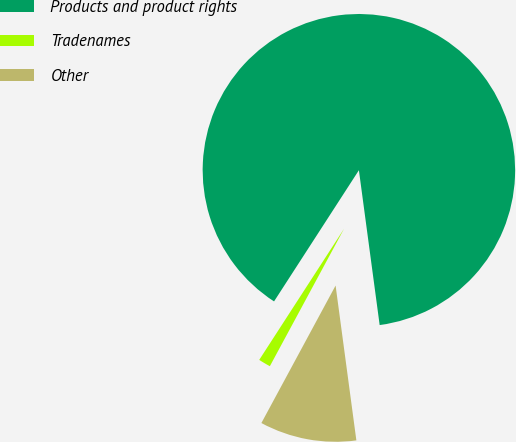Convert chart to OTSL. <chart><loc_0><loc_0><loc_500><loc_500><pie_chart><fcel>Products and product rights<fcel>Tradenames<fcel>Other<nl><fcel>88.74%<fcel>1.26%<fcel>10.0%<nl></chart> 